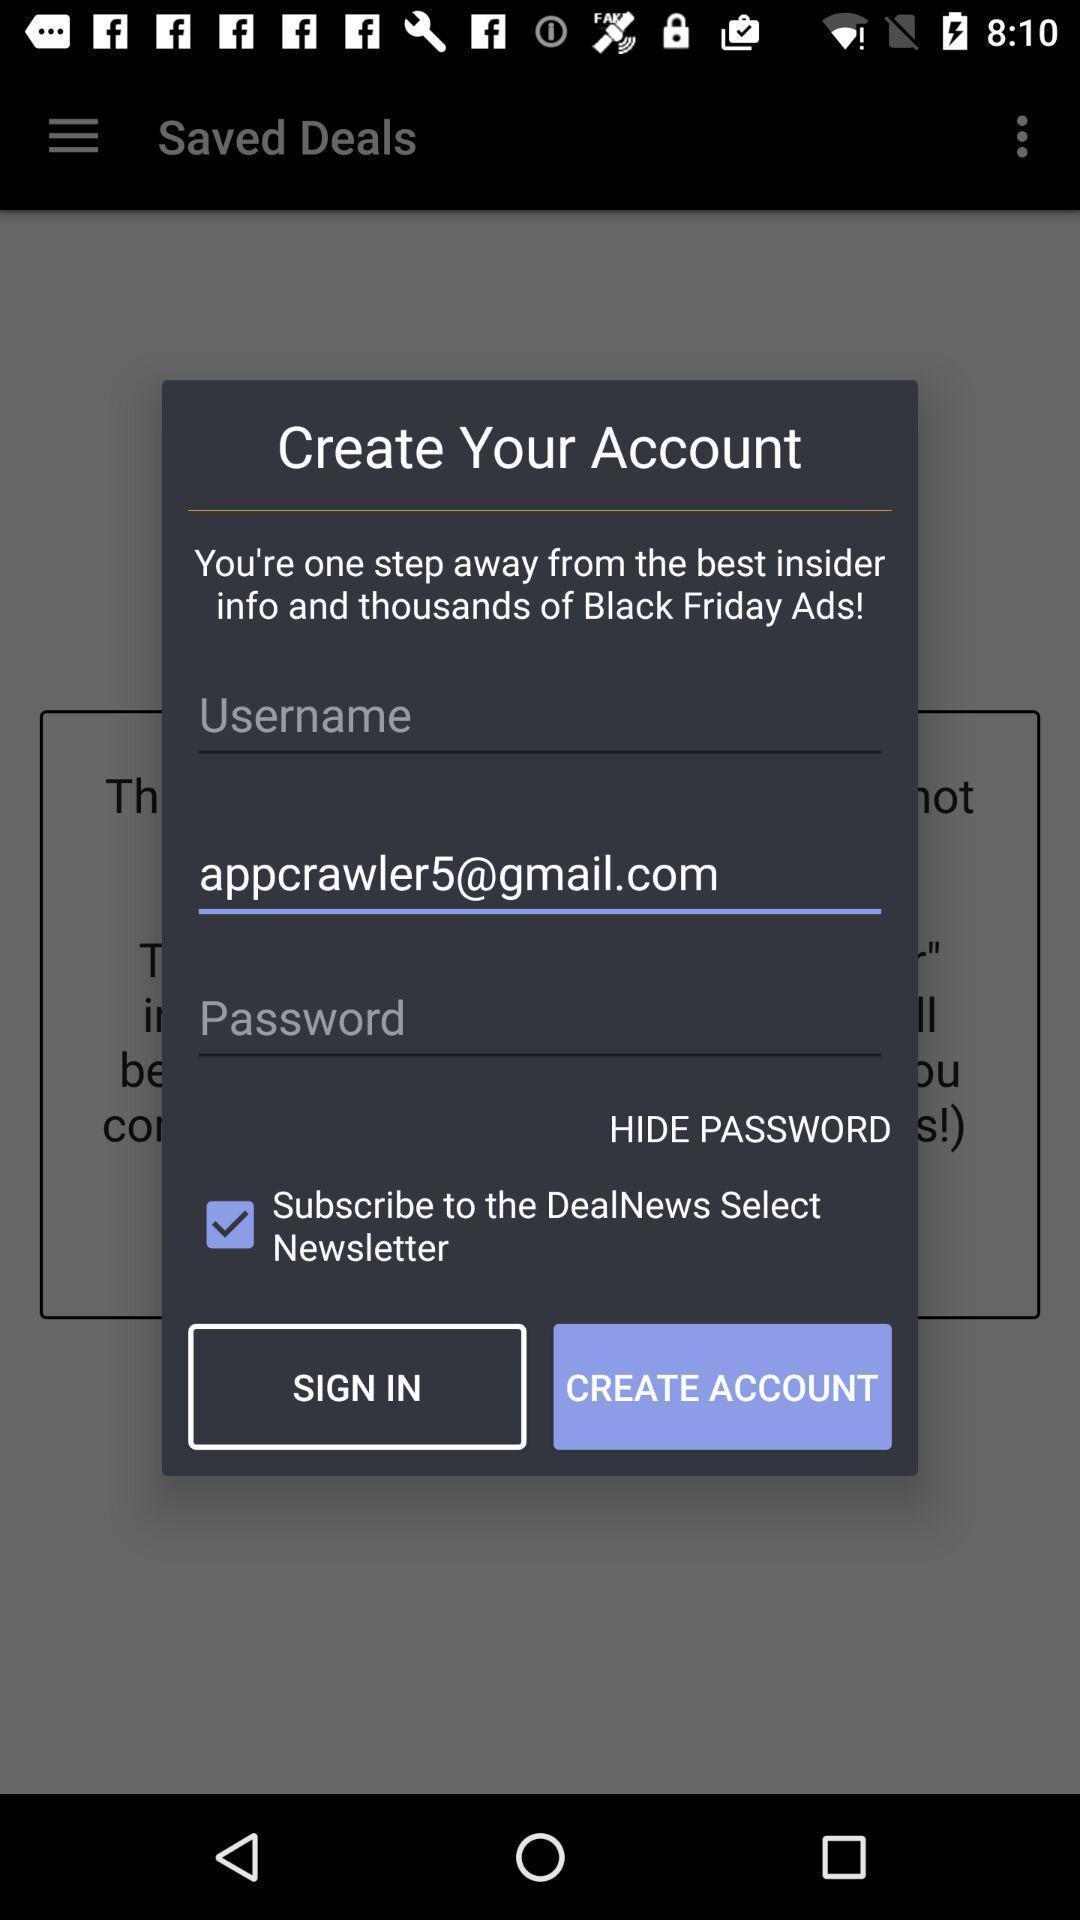Provide a textual representation of this image. Pop-up with account creation options in a deals based app. 